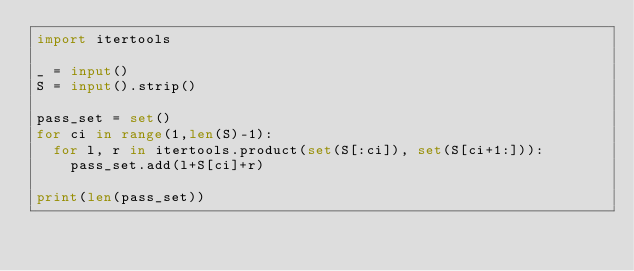<code> <loc_0><loc_0><loc_500><loc_500><_Python_>import itertools

_ = input()
S = input().strip()

pass_set = set()
for ci in range(1,len(S)-1):
  for l, r in itertools.product(set(S[:ci]), set(S[ci+1:])):
    pass_set.add(l+S[ci]+r)

print(len(pass_set))</code> 